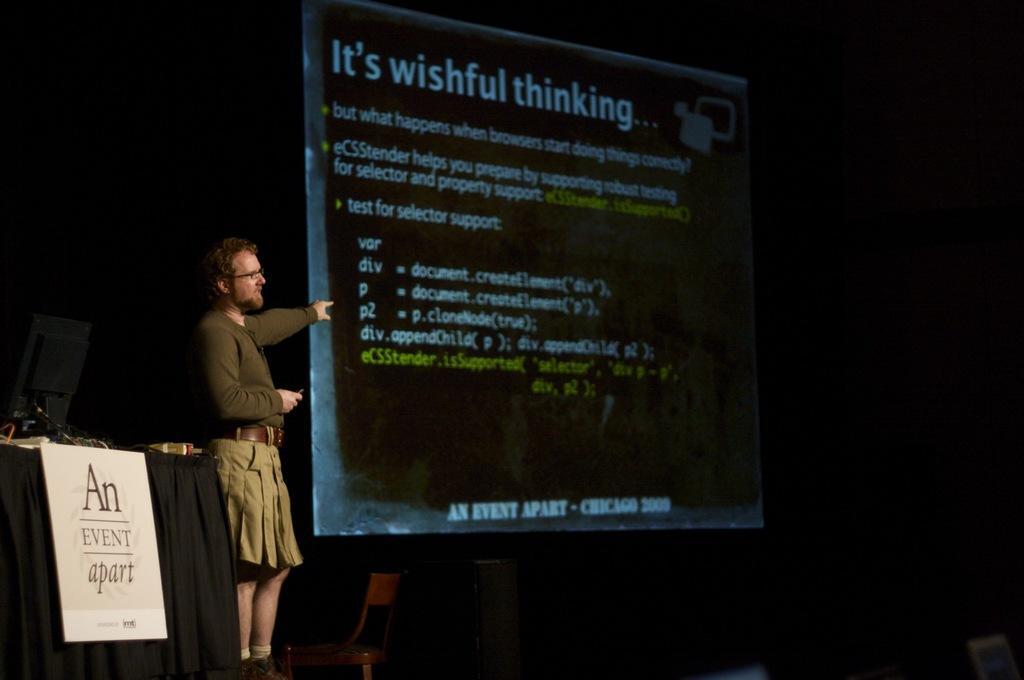Could you give a brief overview of what you see in this image? This image consists of a man is standing on the right. We can see a screen. At the bottom, there is a chair. On the left, we can see a table on which there is a monitor. And the table is covered with a black cloth. On which we can see a poster. The background is too dark. 